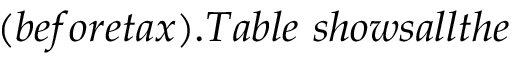Convert formula to latex. <formula><loc_0><loc_0><loc_500><loc_500>( b e f o r e t a x ) . T a b l e s h o w s a l l t h e</formula> 